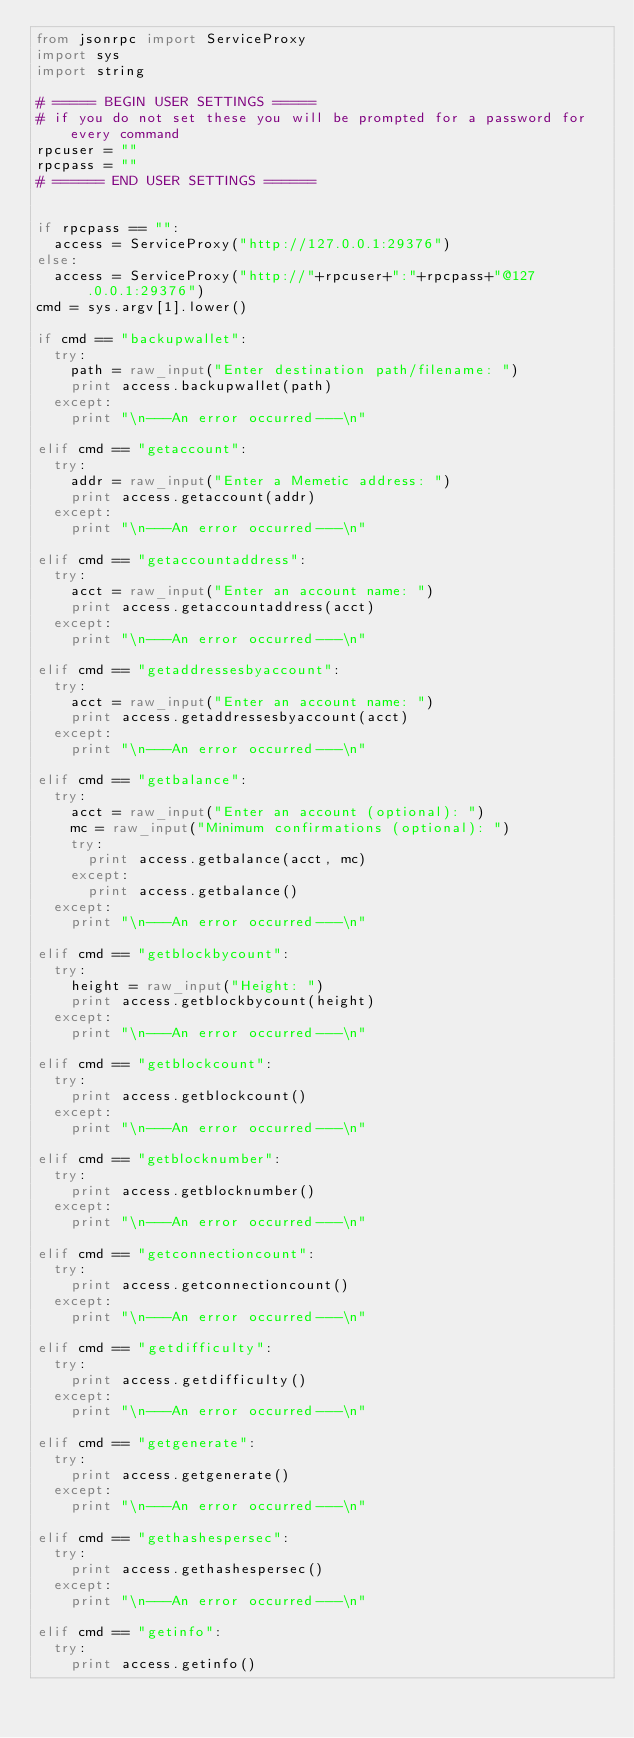Convert code to text. <code><loc_0><loc_0><loc_500><loc_500><_Python_>from jsonrpc import ServiceProxy
import sys
import string

# ===== BEGIN USER SETTINGS =====
# if you do not set these you will be prompted for a password for every command
rpcuser = ""
rpcpass = ""
# ====== END USER SETTINGS ======


if rpcpass == "":
	access = ServiceProxy("http://127.0.0.1:29376")
else:
	access = ServiceProxy("http://"+rpcuser+":"+rpcpass+"@127.0.0.1:29376")
cmd = sys.argv[1].lower()

if cmd == "backupwallet":
	try:
		path = raw_input("Enter destination path/filename: ")
		print access.backupwallet(path)
	except:
		print "\n---An error occurred---\n"

elif cmd == "getaccount":
	try:
		addr = raw_input("Enter a Memetic address: ")
		print access.getaccount(addr)
	except:
		print "\n---An error occurred---\n"

elif cmd == "getaccountaddress":
	try:
		acct = raw_input("Enter an account name: ")
		print access.getaccountaddress(acct)
	except:
		print "\n---An error occurred---\n"

elif cmd == "getaddressesbyaccount":
	try:
		acct = raw_input("Enter an account name: ")
		print access.getaddressesbyaccount(acct)
	except:
		print "\n---An error occurred---\n"

elif cmd == "getbalance":
	try:
		acct = raw_input("Enter an account (optional): ")
		mc = raw_input("Minimum confirmations (optional): ")
		try:
			print access.getbalance(acct, mc)
		except:
			print access.getbalance()
	except:
		print "\n---An error occurred---\n"

elif cmd == "getblockbycount":
	try:
		height = raw_input("Height: ")
		print access.getblockbycount(height)
	except:
		print "\n---An error occurred---\n"

elif cmd == "getblockcount":
	try:
		print access.getblockcount()
	except:
		print "\n---An error occurred---\n"

elif cmd == "getblocknumber":
	try:
		print access.getblocknumber()
	except:
		print "\n---An error occurred---\n"

elif cmd == "getconnectioncount":
	try:
		print access.getconnectioncount()
	except:
		print "\n---An error occurred---\n"

elif cmd == "getdifficulty":
	try:
		print access.getdifficulty()
	except:
		print "\n---An error occurred---\n"

elif cmd == "getgenerate":
	try:
		print access.getgenerate()
	except:
		print "\n---An error occurred---\n"

elif cmd == "gethashespersec":
	try:
		print access.gethashespersec()
	except:
		print "\n---An error occurred---\n"

elif cmd == "getinfo":
	try:
		print access.getinfo()</code> 